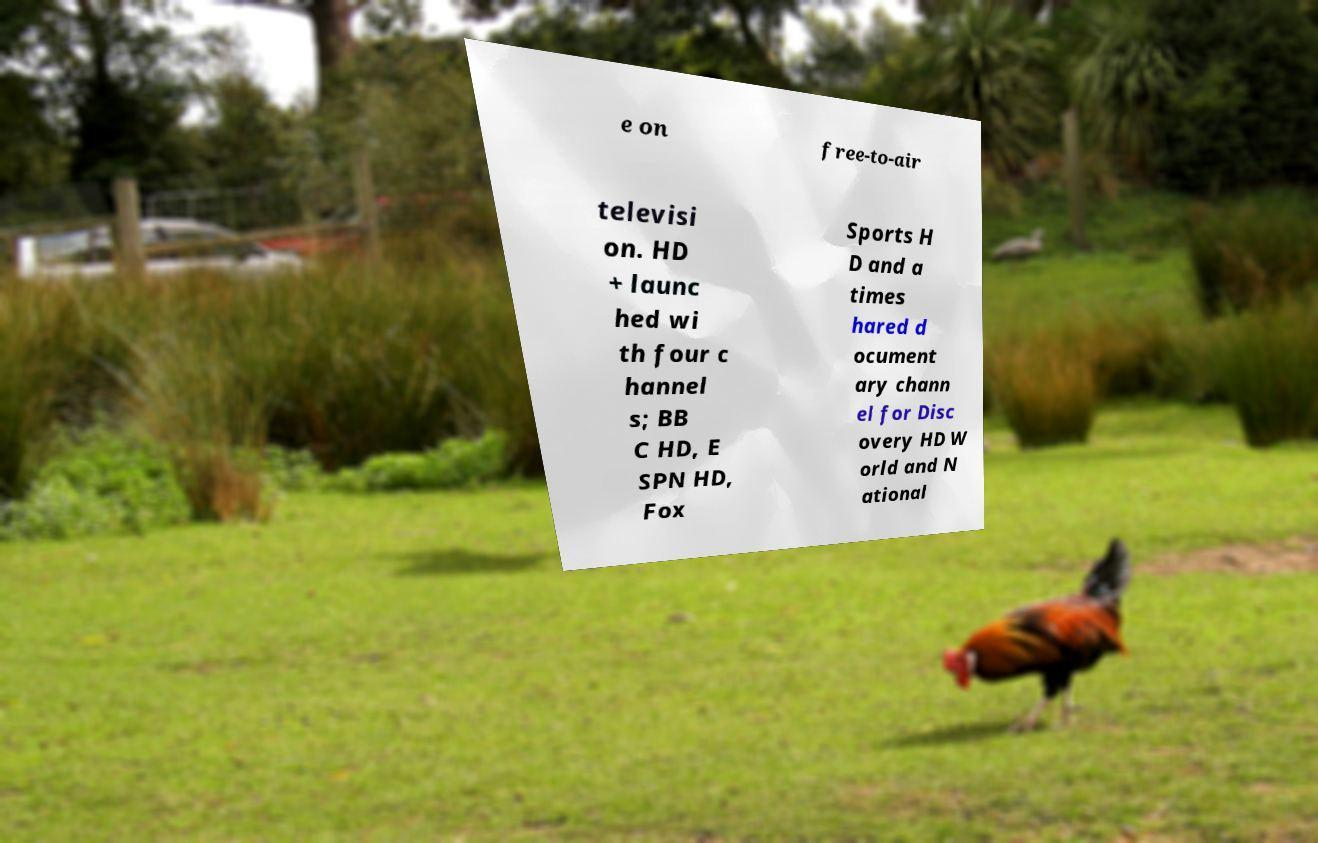For documentation purposes, I need the text within this image transcribed. Could you provide that? e on free-to-air televisi on. HD + launc hed wi th four c hannel s; BB C HD, E SPN HD, Fox Sports H D and a times hared d ocument ary chann el for Disc overy HD W orld and N ational 